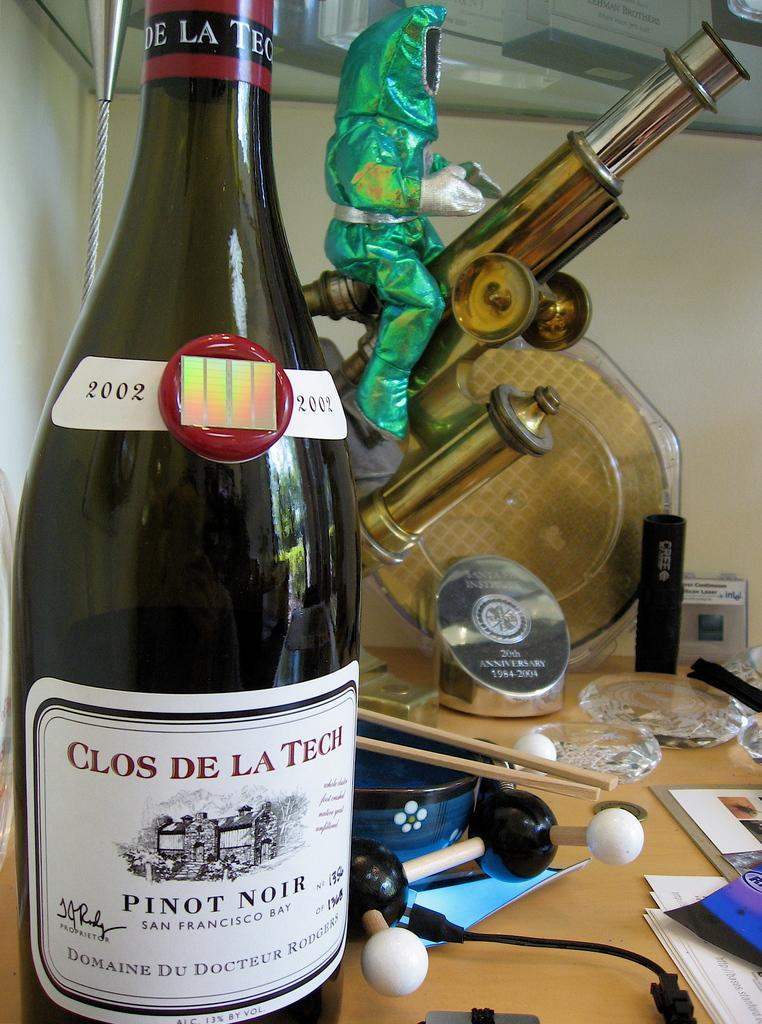<image>
Relay a brief, clear account of the picture shown. A bottle of Clos de La Tech Pinot Noir sits on a messy counter. 